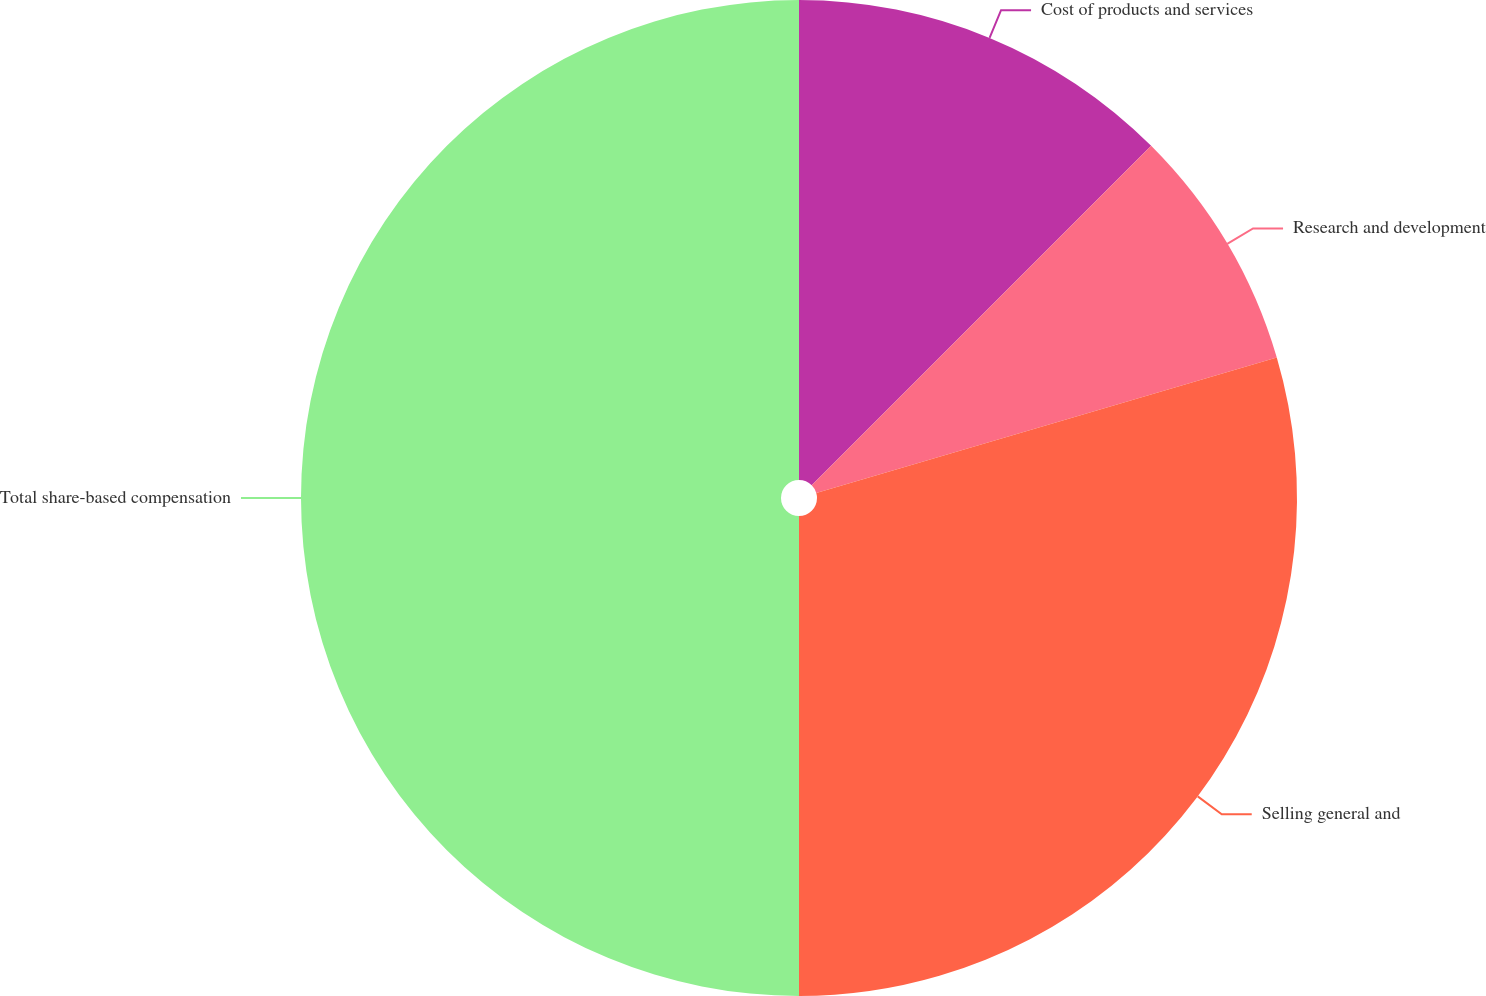Convert chart. <chart><loc_0><loc_0><loc_500><loc_500><pie_chart><fcel>Cost of products and services<fcel>Research and development<fcel>Selling general and<fcel>Total share-based compensation<nl><fcel>12.5%<fcel>7.95%<fcel>29.55%<fcel>50.0%<nl></chart> 